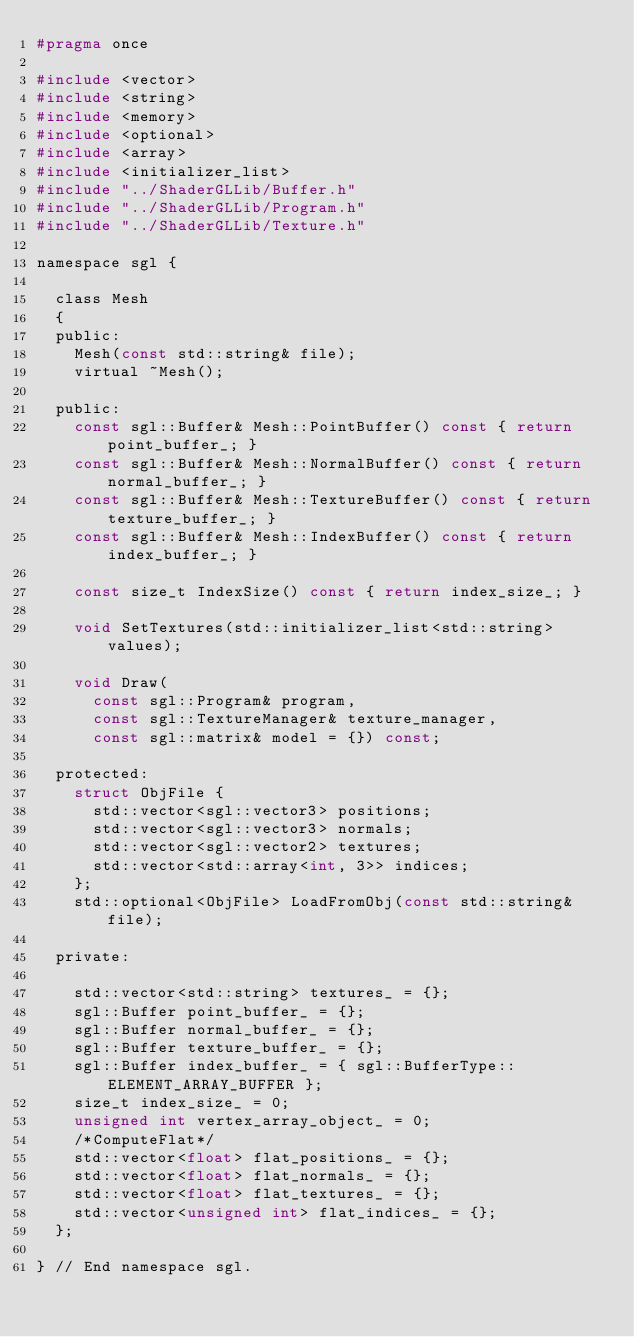<code> <loc_0><loc_0><loc_500><loc_500><_C_>#pragma once

#include <vector>
#include <string>
#include <memory>
#include <optional>
#include <array>
#include <initializer_list>
#include "../ShaderGLLib/Buffer.h"
#include "../ShaderGLLib/Program.h"
#include "../ShaderGLLib/Texture.h"

namespace sgl {

	class Mesh
	{
	public:
		Mesh(const std::string& file);
		virtual ~Mesh();

	public:
		const sgl::Buffer& Mesh::PointBuffer() const { return point_buffer_; }
		const sgl::Buffer& Mesh::NormalBuffer() const {	return normal_buffer_; }
		const sgl::Buffer& Mesh::TextureBuffer() const { return texture_buffer_; }
		const sgl::Buffer& Mesh::IndexBuffer() const { return index_buffer_; }
		
		const size_t IndexSize() const { return index_size_; }
		
		void SetTextures(std::initializer_list<std::string> values);
		
		void Draw(
			const sgl::Program& program,
			const sgl::TextureManager& texture_manager,
			const sgl::matrix& model = {}) const;
		
	protected:
		struct ObjFile {
			std::vector<sgl::vector3> positions;
			std::vector<sgl::vector3> normals;
			std::vector<sgl::vector2> textures;
			std::vector<std::array<int, 3>> indices;
		};
		std::optional<ObjFile> LoadFromObj(const std::string& file);

	private:
		
		std::vector<std::string> textures_ = {};
		sgl::Buffer point_buffer_ = {};
		sgl::Buffer normal_buffer_ = {};
		sgl::Buffer texture_buffer_ = {};
		sgl::Buffer index_buffer_ =	{ sgl::BufferType::ELEMENT_ARRAY_BUFFER };
		size_t index_size_ = 0;
		unsigned int vertex_array_object_ = 0;
		/*ComputeFlat*/
		std::vector<float> flat_positions_ = {};
		std::vector<float> flat_normals_ = {};
		std::vector<float> flat_textures_ = {};
		std::vector<unsigned int> flat_indices_ = {};
	};

} // End namespace sgl.
</code> 